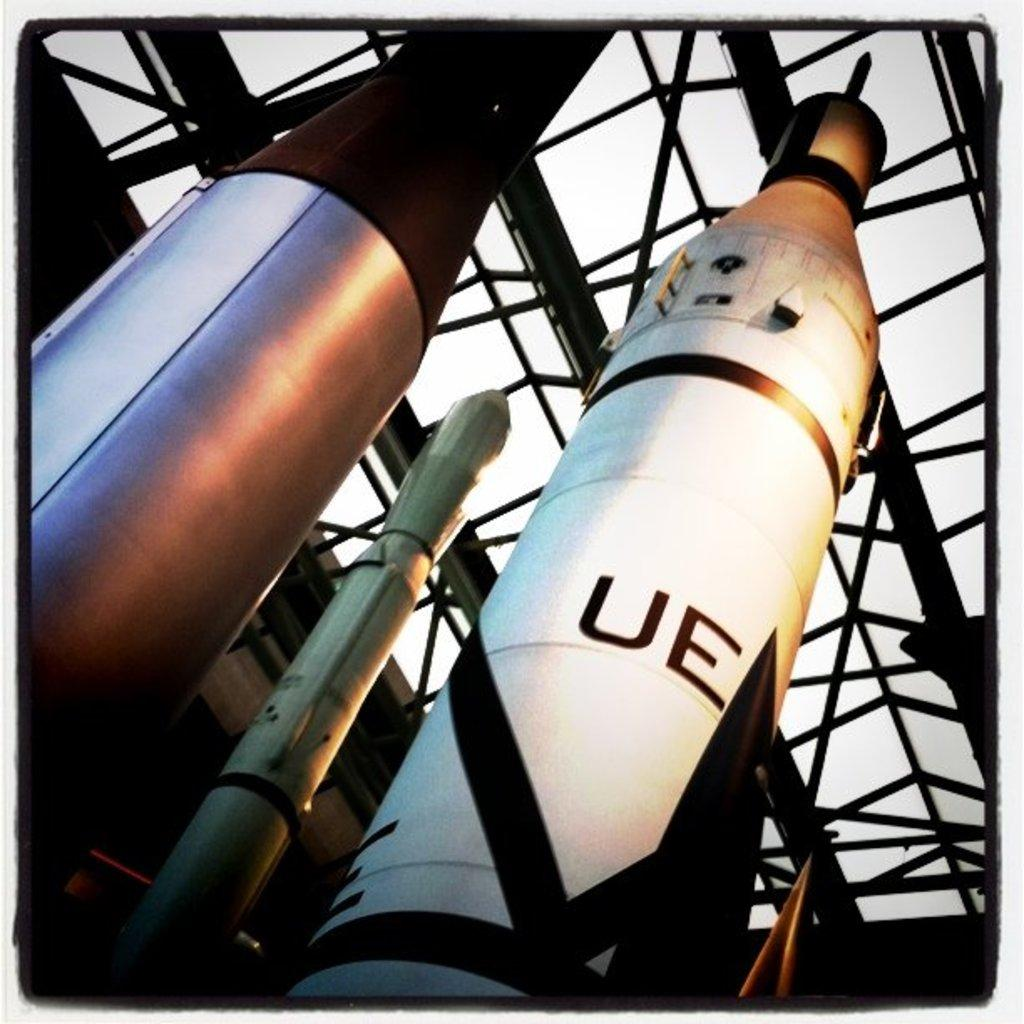What type of structure is depicted in the image? There are parts of an aerospace in the image. What material is used for the frame in the image? The frame in the image is made of metal. What can be seen in the background of the image? The sky is visible in the image. How many pieces of coal can be seen in the image? There is no coal present in the image. What type of fingerprint can be seen on the metal frame in the image? There are no fingerprints visible on the metal frame in the image. 